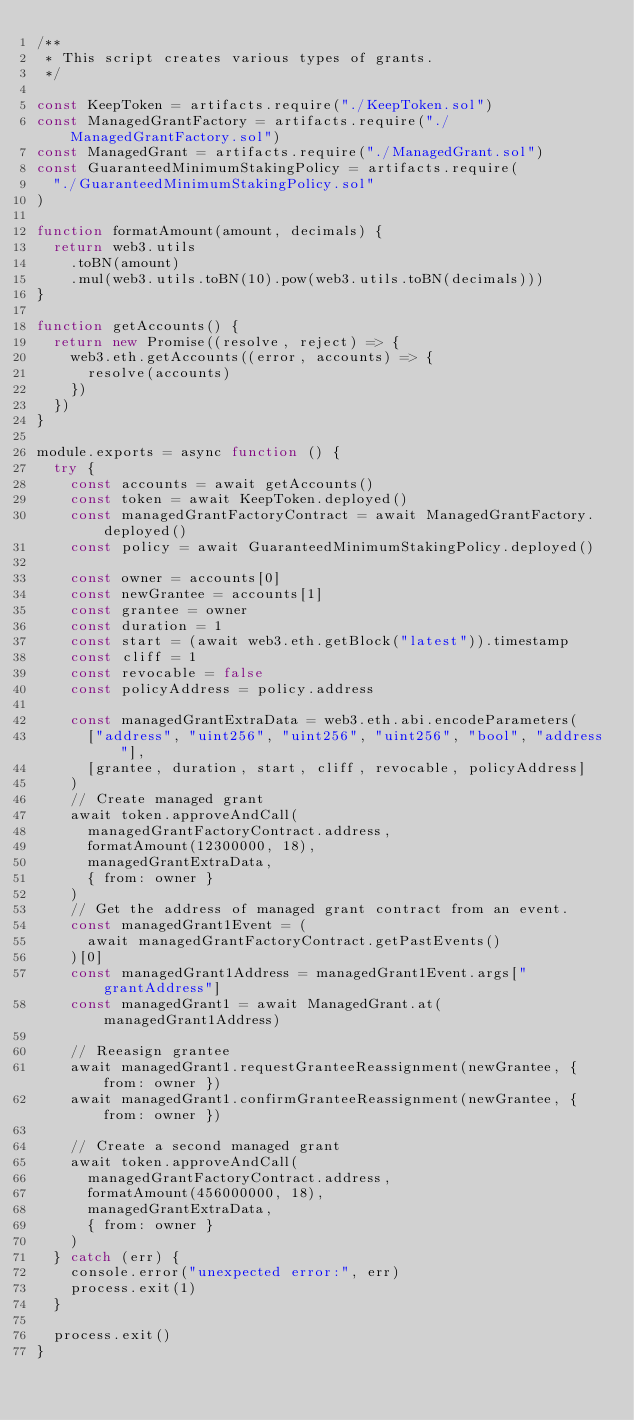<code> <loc_0><loc_0><loc_500><loc_500><_JavaScript_>/**
 * This script creates various types of grants.
 */

const KeepToken = artifacts.require("./KeepToken.sol")
const ManagedGrantFactory = artifacts.require("./ManagedGrantFactory.sol")
const ManagedGrant = artifacts.require("./ManagedGrant.sol")
const GuaranteedMinimumStakingPolicy = artifacts.require(
  "./GuaranteedMinimumStakingPolicy.sol"
)

function formatAmount(amount, decimals) {
  return web3.utils
    .toBN(amount)
    .mul(web3.utils.toBN(10).pow(web3.utils.toBN(decimals)))
}

function getAccounts() {
  return new Promise((resolve, reject) => {
    web3.eth.getAccounts((error, accounts) => {
      resolve(accounts)
    })
  })
}

module.exports = async function () {
  try {
    const accounts = await getAccounts()
    const token = await KeepToken.deployed()
    const managedGrantFactoryContract = await ManagedGrantFactory.deployed()
    const policy = await GuaranteedMinimumStakingPolicy.deployed()

    const owner = accounts[0]
    const newGrantee = accounts[1]
    const grantee = owner
    const duration = 1
    const start = (await web3.eth.getBlock("latest")).timestamp
    const cliff = 1
    const revocable = false
    const policyAddress = policy.address

    const managedGrantExtraData = web3.eth.abi.encodeParameters(
      ["address", "uint256", "uint256", "uint256", "bool", "address"],
      [grantee, duration, start, cliff, revocable, policyAddress]
    )
    // Create managed grant
    await token.approveAndCall(
      managedGrantFactoryContract.address,
      formatAmount(12300000, 18),
      managedGrantExtraData,
      { from: owner }
    )
    // Get the address of managed grant contract from an event.
    const managedGrant1Event = (
      await managedGrantFactoryContract.getPastEvents()
    )[0]
    const managedGrant1Address = managedGrant1Event.args["grantAddress"]
    const managedGrant1 = await ManagedGrant.at(managedGrant1Address)

    // Reeasign grantee
    await managedGrant1.requestGranteeReassignment(newGrantee, { from: owner })
    await managedGrant1.confirmGranteeReassignment(newGrantee, { from: owner })

    // Create a second managed grant
    await token.approveAndCall(
      managedGrantFactoryContract.address,
      formatAmount(456000000, 18),
      managedGrantExtraData,
      { from: owner }
    )
  } catch (err) {
    console.error("unexpected error:", err)
    process.exit(1)
  }

  process.exit()
}
</code> 